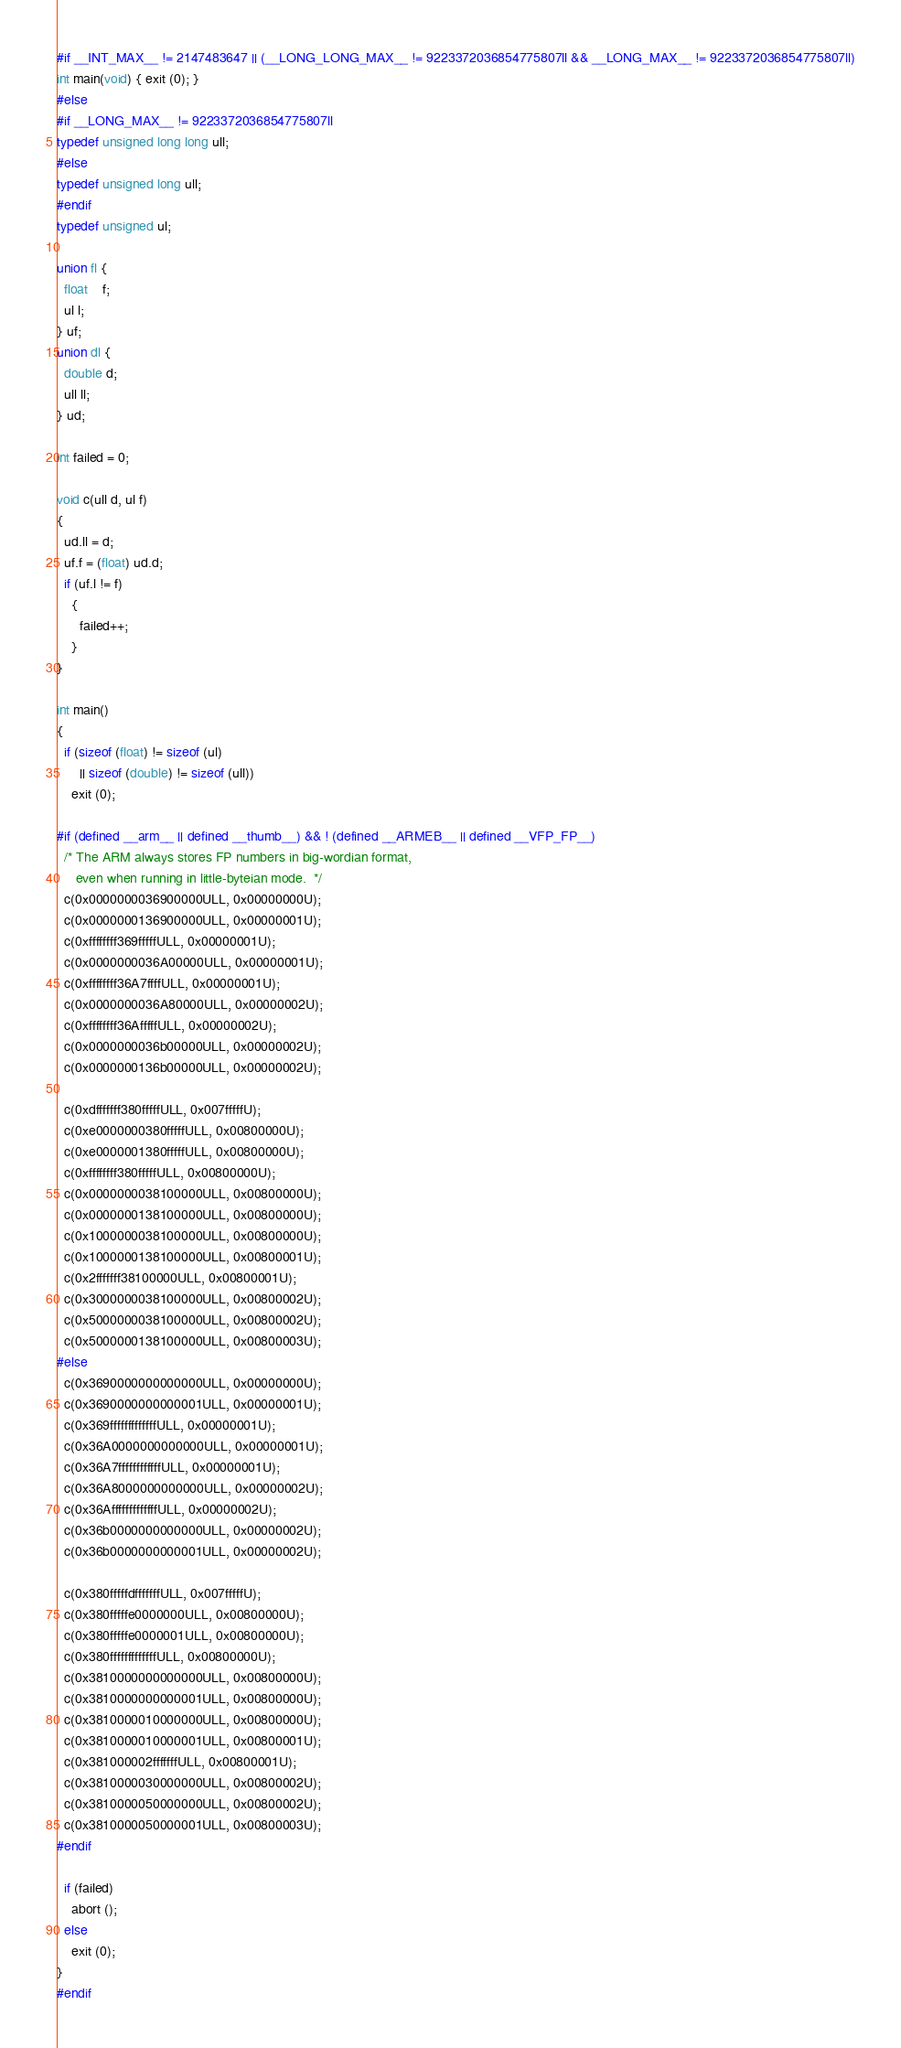<code> <loc_0><loc_0><loc_500><loc_500><_C_>#if __INT_MAX__ != 2147483647 || (__LONG_LONG_MAX__ != 9223372036854775807ll && __LONG_MAX__ != 9223372036854775807ll)
int main(void) { exit (0); }
#else
#if __LONG_MAX__ != 9223372036854775807ll
typedef unsigned long long ull;
#else
typedef unsigned long ull;
#endif
typedef unsigned ul;

union fl {
  float	f;
  ul l;
} uf;
union dl {
  double d;
  ull ll;
} ud;

int failed = 0;

void c(ull d, ul f)
{
  ud.ll = d;
  uf.f = (float) ud.d;
  if (uf.l != f)
    {
      failed++;
    }
}

int main()
{
  if (sizeof (float) != sizeof (ul)
      || sizeof (double) != sizeof (ull))
    exit (0);
  
#if (defined __arm__ || defined __thumb__) && ! (defined __ARMEB__ || defined __VFP_FP__)
  /* The ARM always stores FP numbers in big-wordian format,
     even when running in little-byteian mode.  */
  c(0x0000000036900000ULL, 0x00000000U);
  c(0x0000000136900000ULL, 0x00000001U);
  c(0xffffffff369fffffULL, 0x00000001U);
  c(0x0000000036A00000ULL, 0x00000001U);
  c(0xffffffff36A7ffffULL, 0x00000001U);
  c(0x0000000036A80000ULL, 0x00000002U);
  c(0xffffffff36AfffffULL, 0x00000002U);
  c(0x0000000036b00000ULL, 0x00000002U);
  c(0x0000000136b00000ULL, 0x00000002U);
  
  c(0xdfffffff380fffffULL, 0x007fffffU);
  c(0xe0000000380fffffULL, 0x00800000U);
  c(0xe0000001380fffffULL, 0x00800000U);
  c(0xffffffff380fffffULL, 0x00800000U);
  c(0x0000000038100000ULL, 0x00800000U);
  c(0x0000000138100000ULL, 0x00800000U);
  c(0x1000000038100000ULL, 0x00800000U);
  c(0x1000000138100000ULL, 0x00800001U);
  c(0x2fffffff38100000ULL, 0x00800001U);
  c(0x3000000038100000ULL, 0x00800002U);
  c(0x5000000038100000ULL, 0x00800002U);
  c(0x5000000138100000ULL, 0x00800003U);
#else
  c(0x3690000000000000ULL, 0x00000000U);
  c(0x3690000000000001ULL, 0x00000001U);
  c(0x369fffffffffffffULL, 0x00000001U);
  c(0x36A0000000000000ULL, 0x00000001U);
  c(0x36A7ffffffffffffULL, 0x00000001U);
  c(0x36A8000000000000ULL, 0x00000002U);
  c(0x36AfffffffffffffULL, 0x00000002U);
  c(0x36b0000000000000ULL, 0x00000002U);
  c(0x36b0000000000001ULL, 0x00000002U);
  
  c(0x380fffffdfffffffULL, 0x007fffffU);
  c(0x380fffffe0000000ULL, 0x00800000U);
  c(0x380fffffe0000001ULL, 0x00800000U);
  c(0x380fffffffffffffULL, 0x00800000U);
  c(0x3810000000000000ULL, 0x00800000U);
  c(0x3810000000000001ULL, 0x00800000U);
  c(0x3810000010000000ULL, 0x00800000U);
  c(0x3810000010000001ULL, 0x00800001U);
  c(0x381000002fffffffULL, 0x00800001U);
  c(0x3810000030000000ULL, 0x00800002U);
  c(0x3810000050000000ULL, 0x00800002U);
  c(0x3810000050000001ULL, 0x00800003U);
#endif

  if (failed)
    abort ();
  else
    exit (0);
}
#endif
</code> 